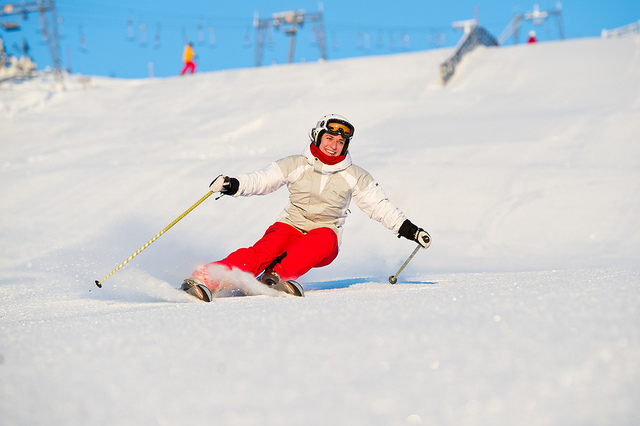How many flowers in the vase are yellow? There is no vase or flowers in the image, instead, it captures an individual skiing down a snowy slope. Therefore, the question is not applicable to the shown image. 